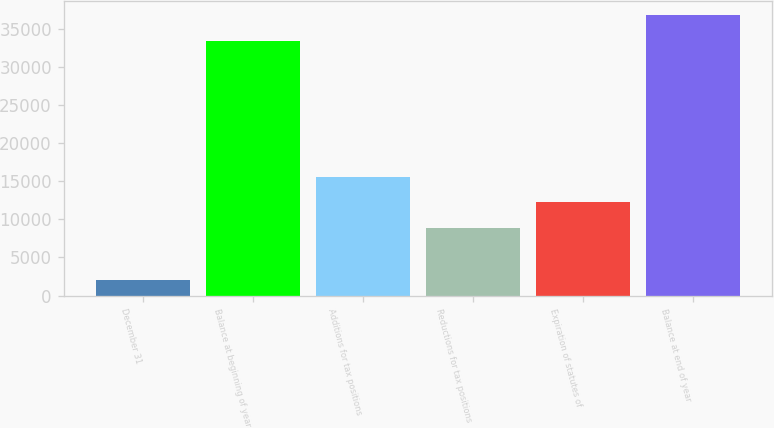Convert chart to OTSL. <chart><loc_0><loc_0><loc_500><loc_500><bar_chart><fcel>December 31<fcel>Balance at beginning of year<fcel>Additions for tax positions<fcel>Reductions for tax positions<fcel>Expiration of statutes of<fcel>Balance at end of year<nl><fcel>2016<fcel>33411<fcel>15610.4<fcel>8813.2<fcel>12211.8<fcel>36809.6<nl></chart> 